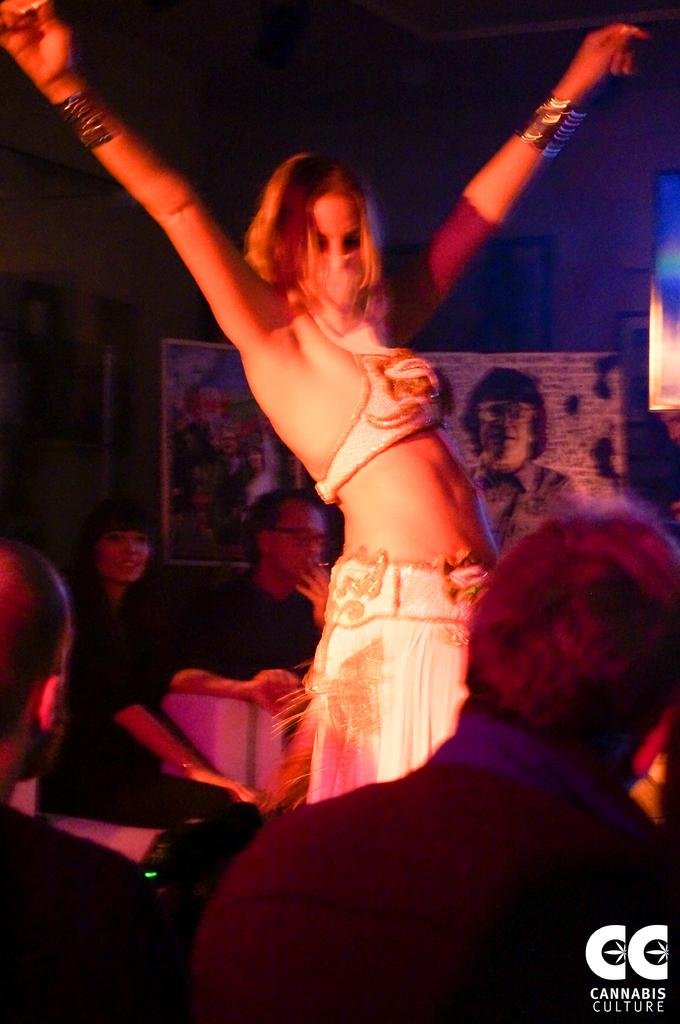What is the main subject of the image? The main subject of the image is a group of people. Can you describe the woman in the image? There is a woman in the middle of the image, and she is standing. Where is the watermark located in the image? The watermark is at the right bottom of the image. What type of alarm can be heard going off in the image? There is no alarm present in the image, and therefore no sound can be heard. 